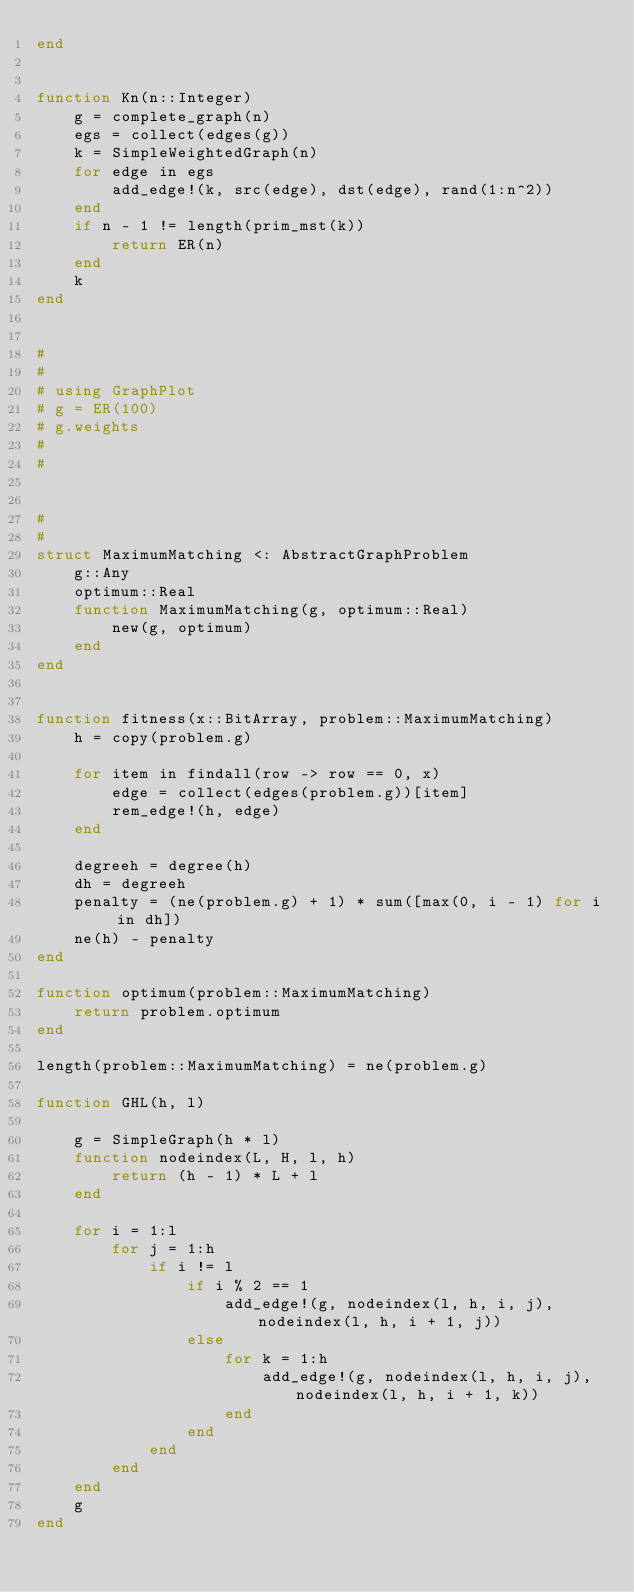Convert code to text. <code><loc_0><loc_0><loc_500><loc_500><_Julia_>end


function Kn(n::Integer)
    g = complete_graph(n)
    egs = collect(edges(g))
    k = SimpleWeightedGraph(n)
    for edge in egs
        add_edge!(k, src(edge), dst(edge), rand(1:n^2))
    end
    if n - 1 != length(prim_mst(k))
        return ER(n)
    end
    k
end


#
#
# using GraphPlot
# g = ER(100)
# g.weights
#
#


#
#
struct MaximumMatching <: AbstractGraphProblem
    g::Any
    optimum::Real
    function MaximumMatching(g, optimum::Real)
        new(g, optimum)
    end
end


function fitness(x::BitArray, problem::MaximumMatching)
    h = copy(problem.g)

    for item in findall(row -> row == 0, x)
        edge = collect(edges(problem.g))[item]
        rem_edge!(h, edge)
    end

    degreeh = degree(h)
    dh = degreeh
    penalty = (ne(problem.g) + 1) * sum([max(0, i - 1) for i in dh])
    ne(h) - penalty
end

function optimum(problem::MaximumMatching)
    return problem.optimum
end

length(problem::MaximumMatching) = ne(problem.g)

function GHL(h, l)

    g = SimpleGraph(h * l)
    function nodeindex(L, H, l, h)
        return (h - 1) * L + l
    end

    for i = 1:l
        for j = 1:h
            if i != l
                if i % 2 == 1
                    add_edge!(g, nodeindex(l, h, i, j), nodeindex(l, h, i + 1, j))
                else
                    for k = 1:h
                        add_edge!(g, nodeindex(l, h, i, j), nodeindex(l, h, i + 1, k))
                    end
                end
            end
        end
    end
    g
end
</code> 